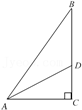How can the concept of similar triangles be demonstrated with this diagram? In this diagram, triangle ADE and triangle ABC are similar by AA similarity criterion (angle-angle). Both triangles contain a right angle and share angle A. The properties of similar triangles can be used to derive ratios between corresponding sides which are proportional. What practical applications might these geometric principles have? These principles are used in various real-world applications such as in architecture for ensuring structures are stable and balanced, in navigation systems to calculate distances and routes, and in physics for solving problems related to forces and motion. 